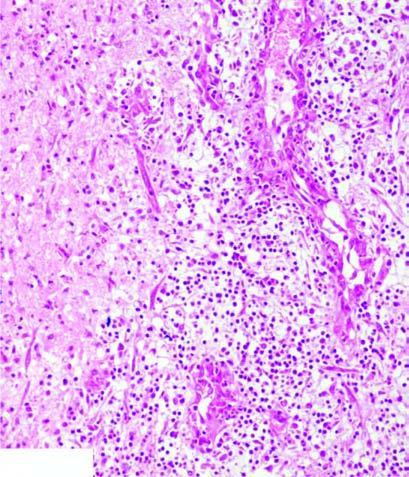does there show a cystic space containing cell debris, while the surrounding zone shows granulation tissue and gliosis?
Answer the question using a single word or phrase. No 